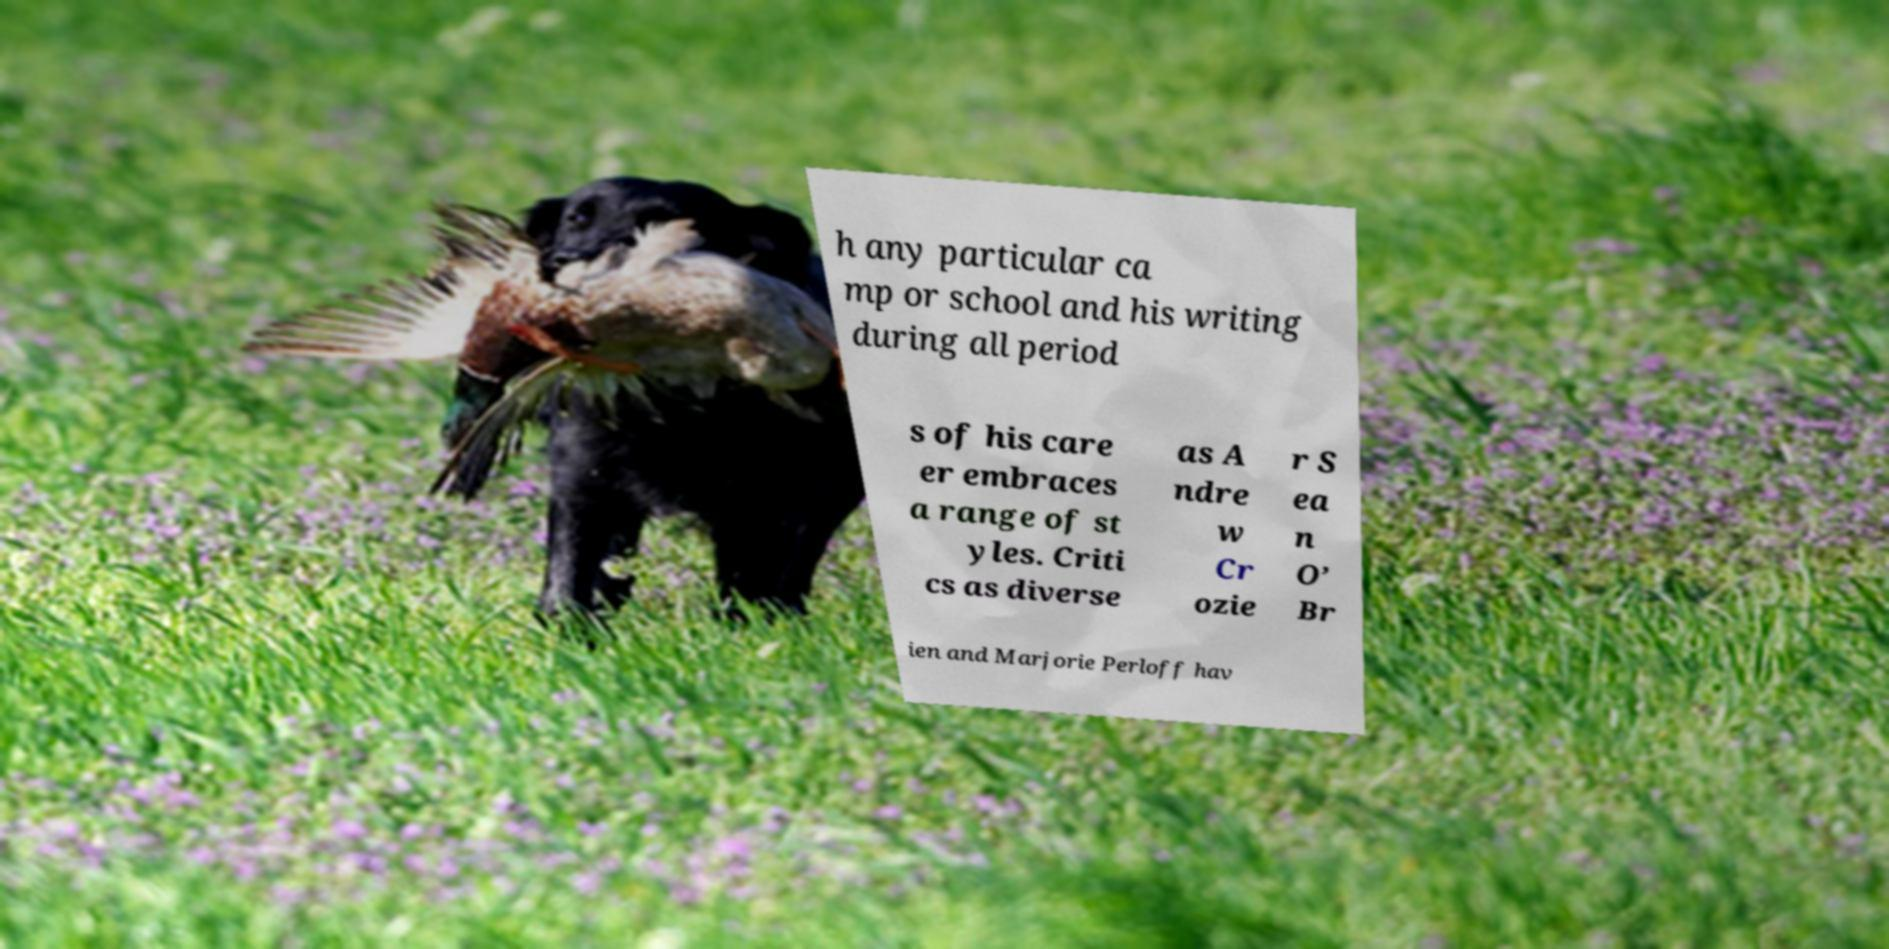Please identify and transcribe the text found in this image. h any particular ca mp or school and his writing during all period s of his care er embraces a range of st yles. Criti cs as diverse as A ndre w Cr ozie r S ea n O’ Br ien and Marjorie Perloff hav 